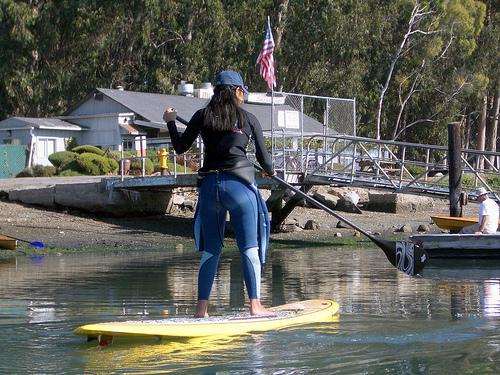Describe the location where the paddleboarding is taking place. The paddleboarding is happening near a lake shore with a dock, small bridge, and chain link fence on the shore. What is the color and type of the paddle the woman is holding? The woman is holding a black and silver paddle. Identify the activity the woman is participating in and describe her clothing. The woman is paddle boarding while wearing a blue hat, black swimwear shirt, blue swimwear pants, and a partially pulled-down blue wet suit. Count and describe the different watercraft types in the image. There are three watercraft types: a yellow paddle board, a metal rowboat, and a yellow rowboat. Mention the object that is a part of the man's outfit and its color. The man is wearing a white hat on his head. What objects are in close proximity to the woman as she stands on the paddleboard? Near the woman, there is a yellow paddle board, lake shore, and a dock. Which part of the woman's outfit appears to be partially removed or adjusted? The wet suit is pulled down, revealing the black swimwear shirt underneath. List all the usa flag-related objects and their sizes in the image. Large American flag on the pole (Width:68, Height:68), a red white and blue American flag (Width:23, Height:23), a silver flagpole (Width:10, Height:10), and United States of America flag (Width:80, Height:80). How many American flags can be seen in the image and what is unique about each one? There are three American flags visible, one on a large flagpole, one smaller red white and blue flag, and one on a smaller pole, each with different sizes. 